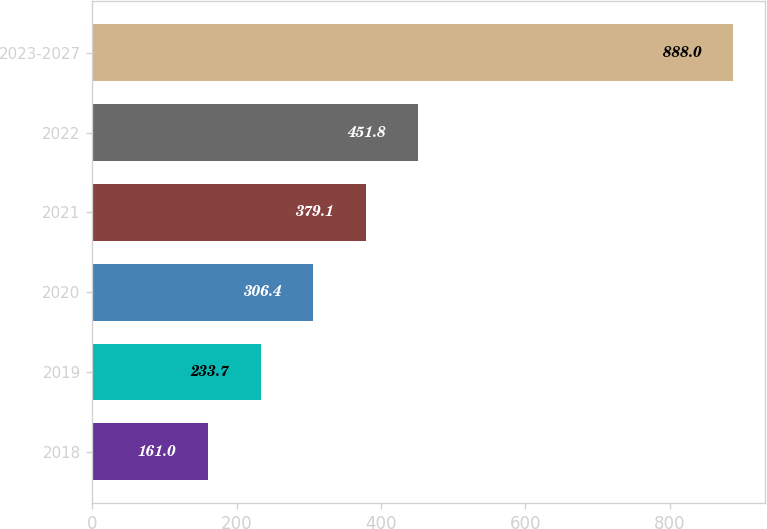Convert chart to OTSL. <chart><loc_0><loc_0><loc_500><loc_500><bar_chart><fcel>2018<fcel>2019<fcel>2020<fcel>2021<fcel>2022<fcel>2023-2027<nl><fcel>161<fcel>233.7<fcel>306.4<fcel>379.1<fcel>451.8<fcel>888<nl></chart> 